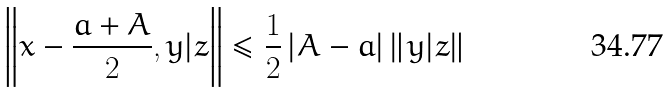Convert formula to latex. <formula><loc_0><loc_0><loc_500><loc_500>\left \| x - \frac { a + A } { 2 } , y | z \right \| \leq \frac { 1 } { 2 } \left | A - a \right | \left \| y | z \right \|</formula> 